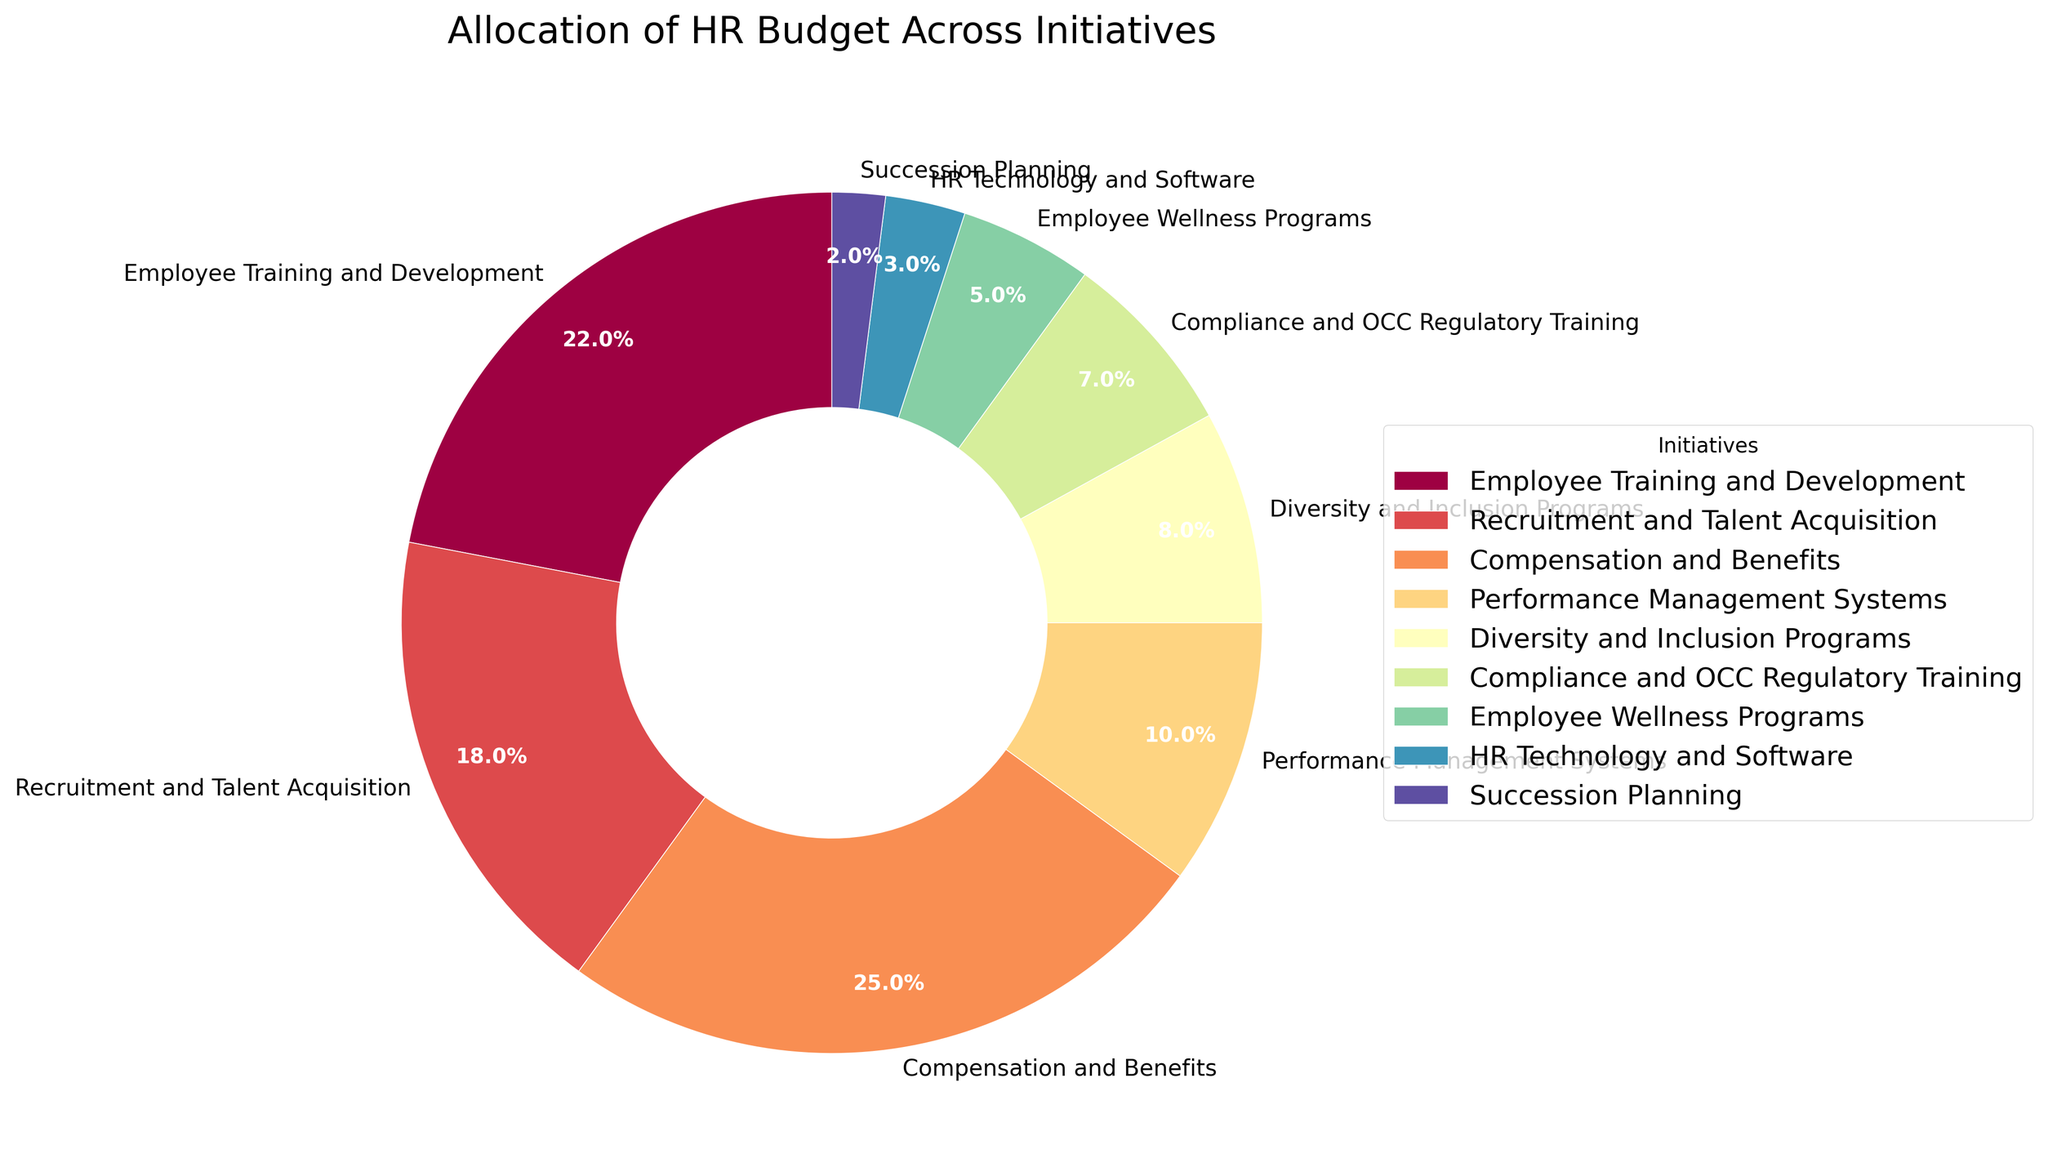What is the largest allocation in the HR budget? By looking at the pie chart, the largest section corresponds to "Compensation and Benefits". This is the segment that takes up the largest proportion of the pie, indicating the highest budget allocation.
Answer: Compensation and Benefits What is the smallest allocation in the HR budget? Observing the pie chart, the smallest section is labeled as "Succession Planning". This appears to be the smallest slice of the pie, which means it has the smallest budget allocation.
Answer: Succession Planning Which initiative receives more funding: Employee Training and Development or Recruitment and Talent Acquisition? Comparing the sizes of the two segments labeled "Employee Training and Development" and "Recruitment and Talent Acquisition," the former is slightly larger than the latter.
Answer: Employee Training and Development What is the combined budget percentage for Diversity and Inclusion Programs and Employee Wellness Programs? From the pie chart, the budget percentage for Diversity and Inclusion Programs is 8% and for Employee Wellness Programs is 5%. Adding these two percentages together gives 8% + 5% = 13%.
Answer: 13% Is the allocation for Compliance and OCC Regulatory Training more than the allocation for HR Technology and Software? Observing the segments labeled "Compliance and OCC Regulatory Training" and "HR Technology and Software," the former has a larger slice compared to the latter. Compliance and OCC Regulatory Training has a 7% allocation, whereas HR Technology and Software has a 3% allocation.
Answer: Yes How does the allocation for Performance Management Systems compare to the allocation for Succession Planning? The pie chart shows that the segment for "Performance Management Systems" is larger than that for "Succession Planning." Specifically, Performance Management Systems receive 10%, while Succession Planning receives 2%.
Answer: Performance Management Systems has a higher allocation Which initiatives have a budget allocation of less than 10%? By examining the pie chart, the initiatives with a budget allocation of less than 10% are "Diversity and Inclusion Programs" (8%), "Compliance and OCC Regulatory Training" (7%), "Employee Wellness Programs" (5%), "HR Technology and Software" (3%), and "Succession Planning" (2%).
Answer: Diversity and Inclusion Programs, Compliance and OCC Regulatory Training, Employee Wellness Programs, HR Technology and Software, Succession Planning What percentage of the HR budget is allocated to initiatives other than Compensation and Benefits? The total HR budget percentage is 100%. Compensation and Benefits has a 25% allocation. Subtracting this from 100% gives 100% - 25% = 75%.
Answer: 75% Which initiative has the second-highest budget allocation? From the pie chart, the second-largest slice after "Compensation and Benefits" is "Employee Training and Development", which has a 22% allocation.
Answer: Employee Training and Development How much more budget is allocated to Compensation and Benefits than Compliance and OCC Regulatory Training? The budget percentage for Compensation and Benefits is 25%, and for Compliance and OCC Regulatory Training, it is 7%. The difference is 25% - 7% = 18%.
Answer: 18% 